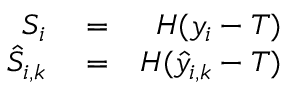<formula> <loc_0><loc_0><loc_500><loc_500>\begin{array} { r l r } { S _ { i } } & = } & { H ( y _ { i } - T ) } \\ { \hat { S } _ { i , k } } & = } & { H ( \hat { y } _ { i , k } - T ) } \end{array}</formula> 